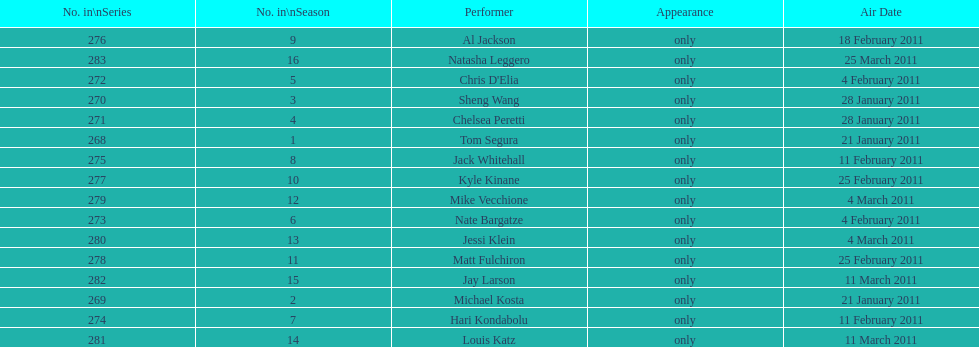Which month featured the highest number of performers? February. 